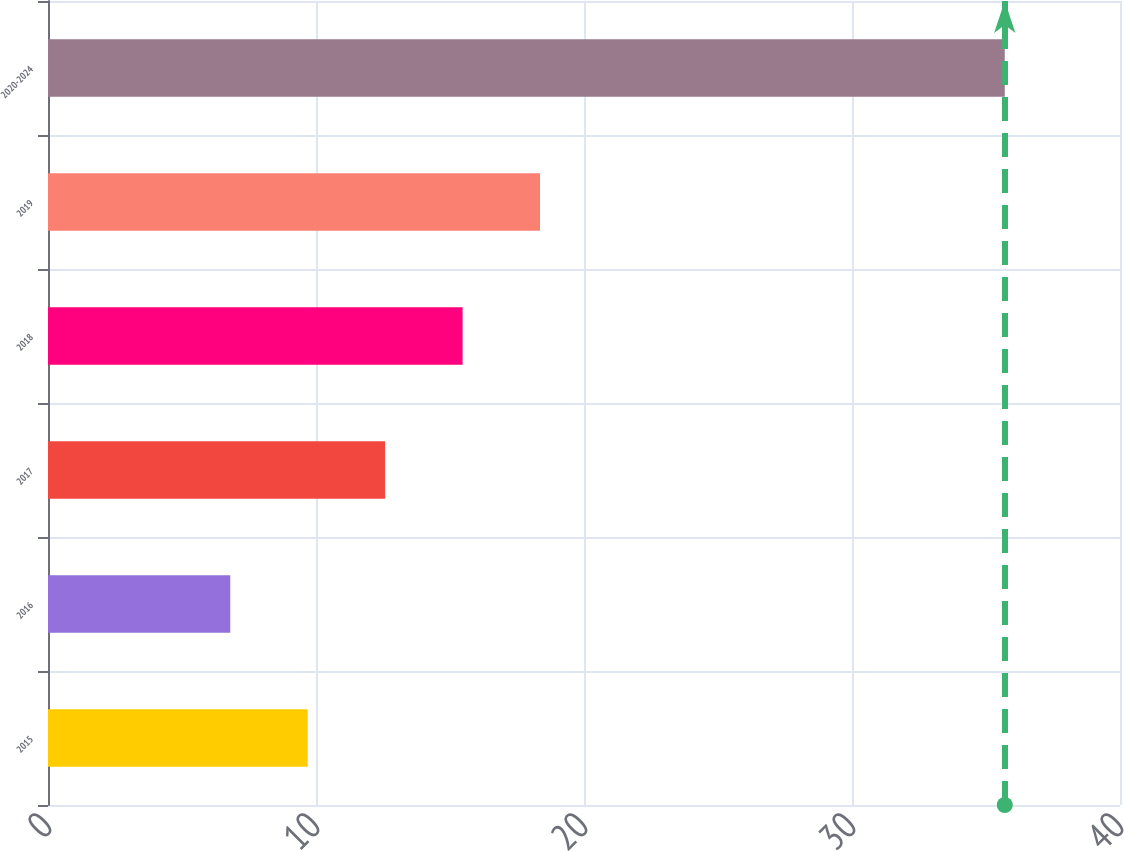Convert chart. <chart><loc_0><loc_0><loc_500><loc_500><bar_chart><fcel>2015<fcel>2016<fcel>2017<fcel>2018<fcel>2019<fcel>2020-2024<nl><fcel>9.69<fcel>6.8<fcel>12.58<fcel>15.47<fcel>18.36<fcel>35.7<nl></chart> 